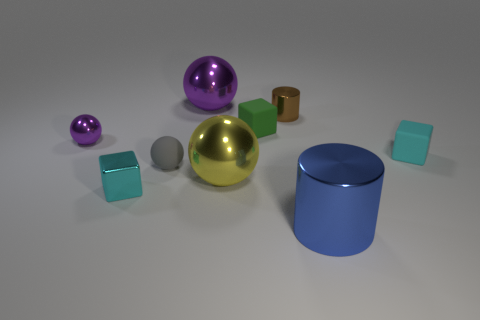Subtract 1 balls. How many balls are left? 3 Subtract all blocks. How many objects are left? 6 Add 4 tiny red matte cylinders. How many tiny red matte cylinders exist? 4 Subtract 0 purple cubes. How many objects are left? 9 Subtract all small matte balls. Subtract all green rubber things. How many objects are left? 7 Add 3 yellow metallic things. How many yellow metallic things are left? 4 